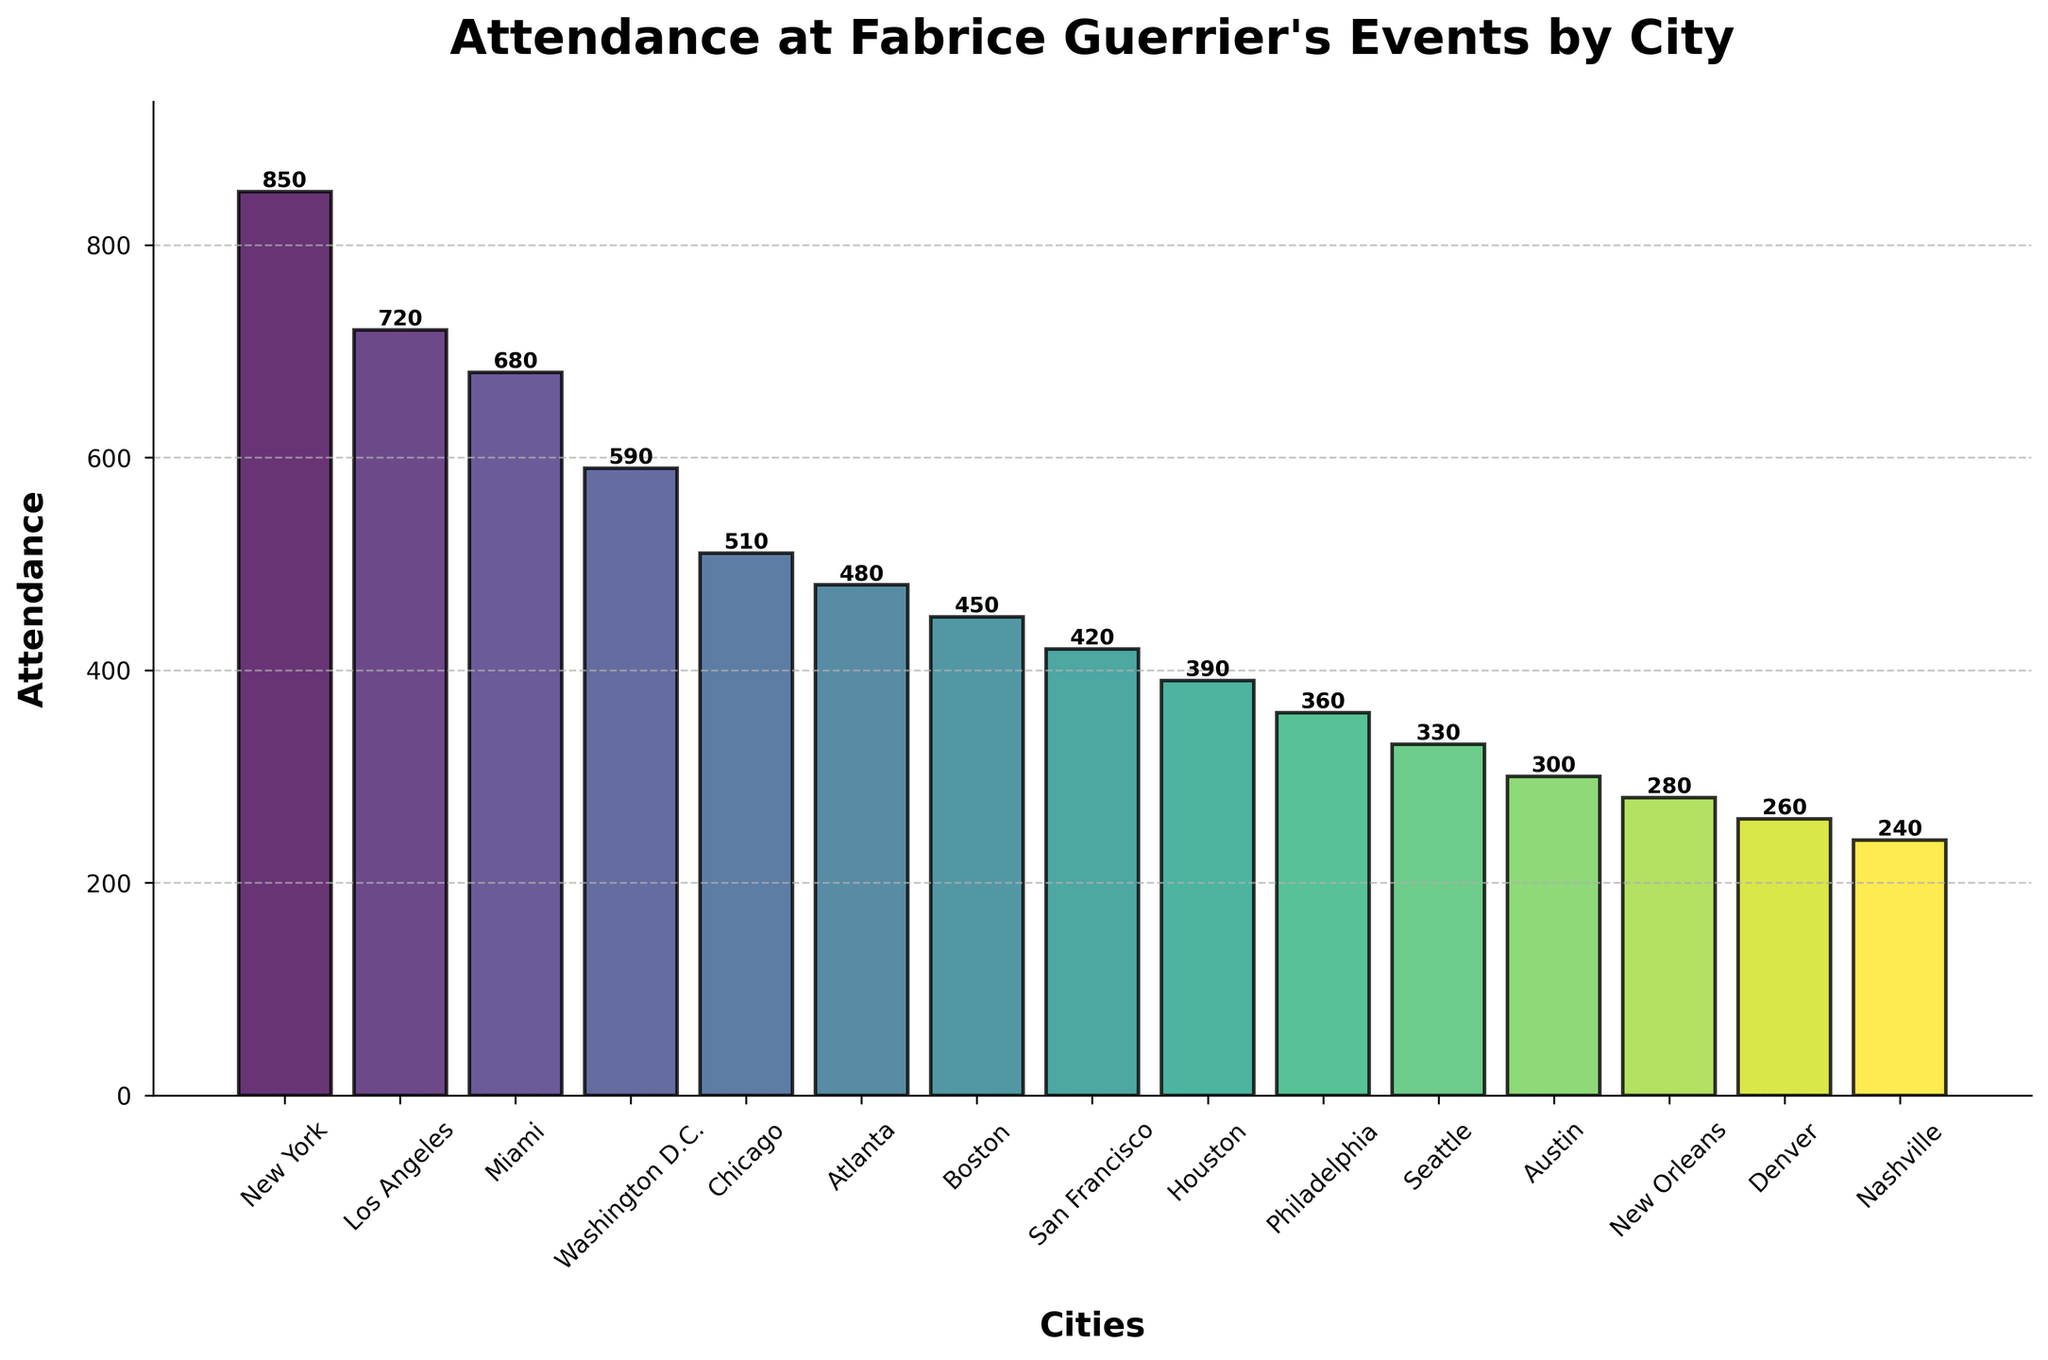What city had the highest attendance at Fabrice Guerrier's events? The city with the highest attendance corresponds to the tallest bar in the bar chart. By looking at the figure, we see that the tallest bar is labeled "New York".
Answer: New York Which city had the lowest attendance at Fabrice Guerrier's events? The city with the lowest attendance corresponds to the shortest bar in the bar chart. By observing the figure, we see that the shortest bar is labeled "Nashville".
Answer: Nashville How much higher is the attendance in New York compared to Los Angeles? First, find the attendance numbers for New York and Los Angeles from their respective bars. New York had an attendance of 850, and Los Angeles had 720. Subtract Los Angeles' attendance from New York's attendance: 850 - 720 = 130.
Answer: 130 What is the average attendance across all cities? Add up the attendance numbers for all cities and then divide by the number of cities (15). The total attendance is 850 + 720 + 680 + 590 + 510 + 480 + 450 + 420 + 390 + 360 + 330 + 300 + 280 + 260 + 240 = 6,860. Divide by 15 to get the average: 6,860 / 15 ≈ 457.33.
Answer: 457.33 Which city had an attendance closest to the calculated average? The calculated average attendance is ≈457.33. Comparing it to the attendance values in the figure, Boston had 450, which is the closest to 457.33.
Answer: Boston Are there more cities with attendance above or below 500? Count the number of bars that represent attendance above 500 and those below 500. There are five bars above 500 (New York, Los Angeles, Miami, Washington D.C., Chicago) and ten bars below 500 (Atlanta, Boston, San Francisco, Houston, Philadelphia, Seattle, Austin, New Orleans, Denver, Nashville). More cities have attendance below 500.
Answer: Below Which three cities had the lowest attendance numbers? By examining the shortest bars in the bar chart, we see the three cities with the lowest attendance are Nashville (240), Denver (260), and New Orleans (280).
Answer: Nashville, Denver, New Orleans Is there a larger attendance difference between New York and Los Angeles or between Philadelphia and Austin? Calculate the difference between New York and Los Angeles' attendances: 850 - 720 = 130. Then calculate the difference between Philadelphia and Austin's attendances: 360 - 300 = 60. The difference between New York and Los Angeles is larger.
Answer: New York and Los Angeles Which city had an attendance just above 500? Observing the bar heights and their labels, we see that Chicago had an attendance of 510, which is just above 500.
Answer: Chicago 